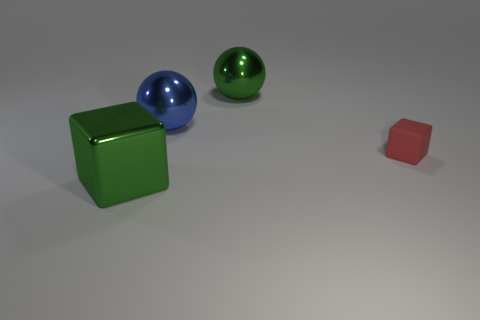What could be the possible sizes of these objects in real-world terms? Given the scale provided by the image, the large green cube could be similar in size to a small footstool. The small red cube might be comparable to a dice or a child's building block, while the blue and green spheres could vary from the size of a baseball to that of a small bowling ball, respectively. Are there any indications of the materials the objects are made from? Yes, the large green cube and small red cube appear to have a matte texture, suggesting a plastic or painted wood surface. The blue sphere has reflective qualities indicative of a polished metal surface, while the green sphere's slight reflections and less polished look might suggest a ceramic or coated wood material. 